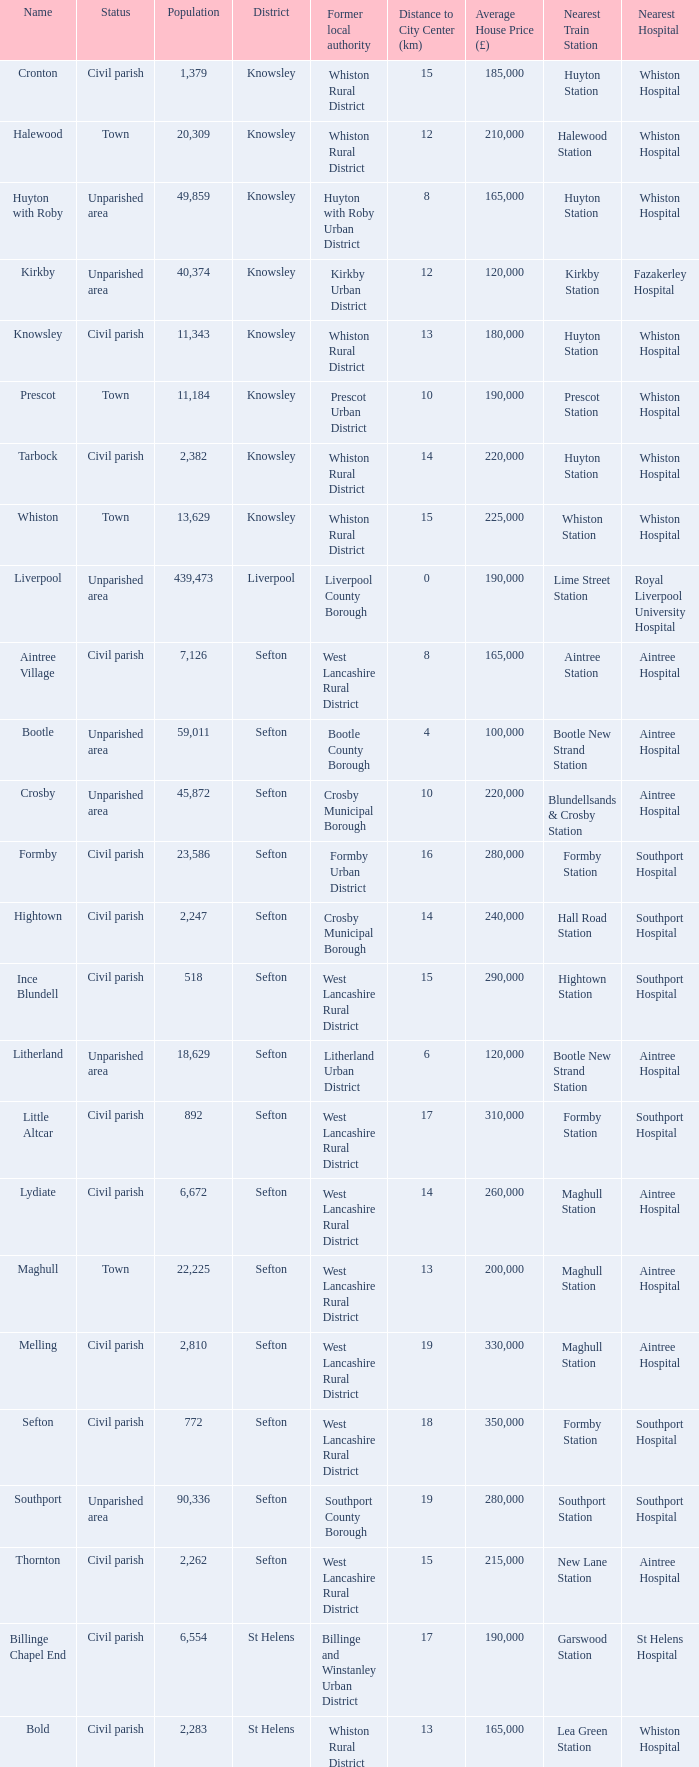What is the district of wallasey Wirral. 